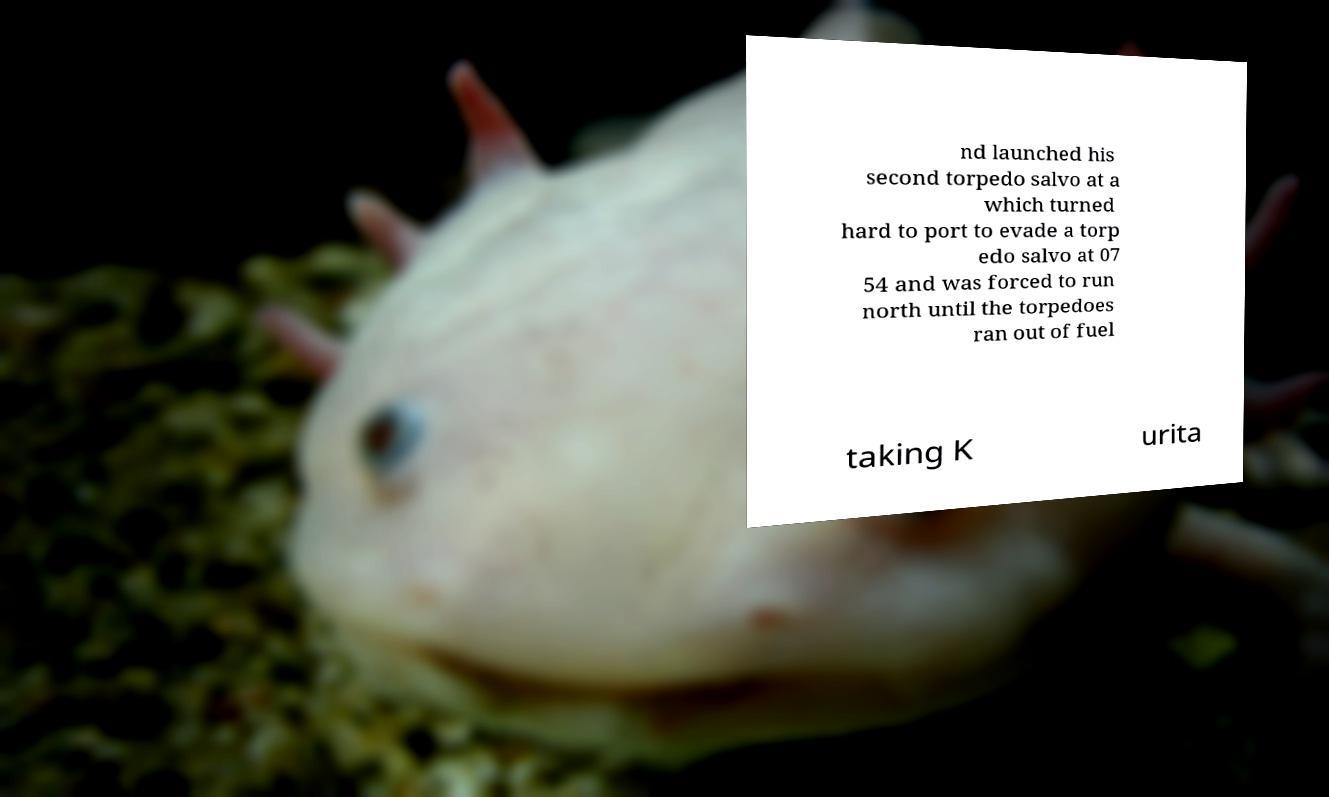Please read and relay the text visible in this image. What does it say? nd launched his second torpedo salvo at a which turned hard to port to evade a torp edo salvo at 07 54 and was forced to run north until the torpedoes ran out of fuel taking K urita 